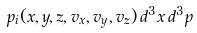Convert formula to latex. <formula><loc_0><loc_0><loc_500><loc_500>p _ { i } ( x , y , z , v _ { x } , v _ { y } , v _ { z } ) \, d ^ { 3 } x \, d ^ { 3 } p</formula> 